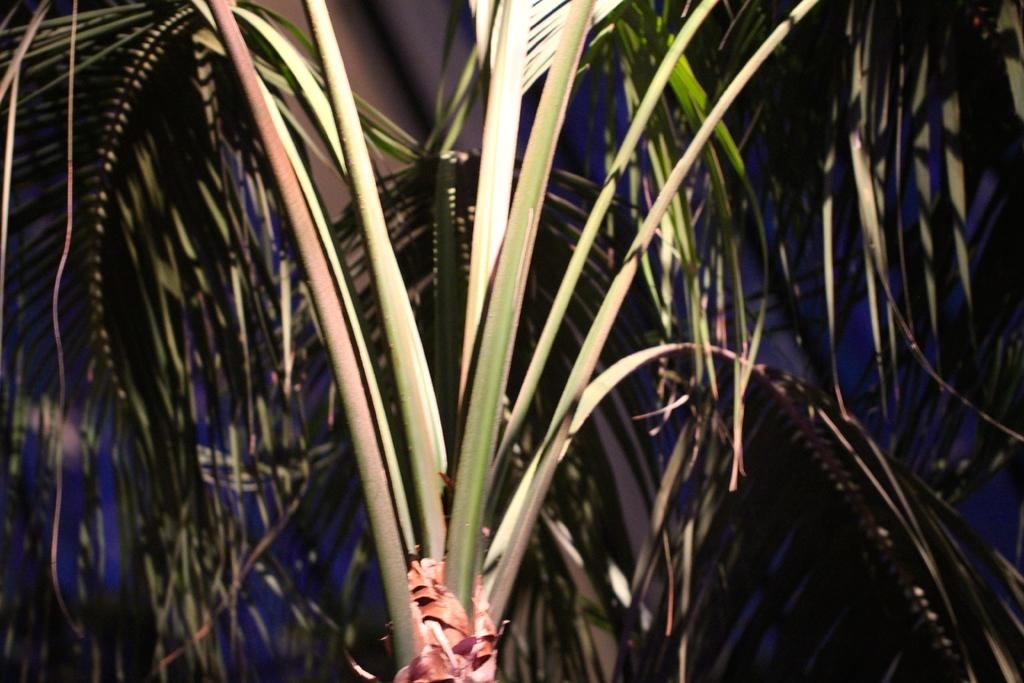What type of plant can be seen in the image? There is a tree in the image. What is the color of the tree in the image? The tree is green in color. What else can be seen in the image besides the tree? There is a sky visible in the image. What type of shirt is hanging on the tree in the image? There is no shirt hanging on the tree in the image; it is a green tree with no additional objects. 